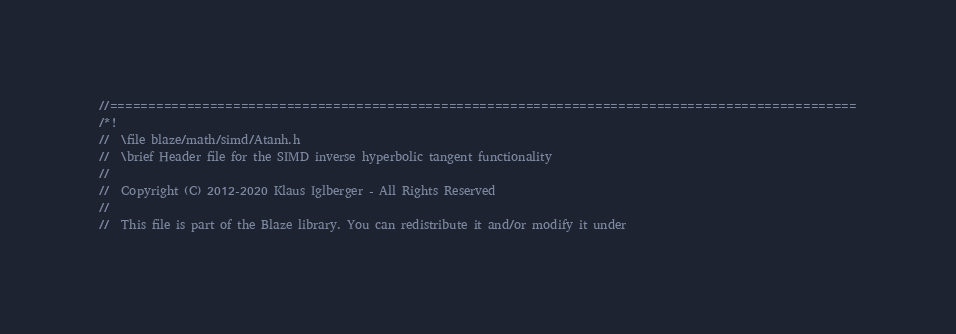<code> <loc_0><loc_0><loc_500><loc_500><_C_>//=================================================================================================
/*!
//  \file blaze/math/simd/Atanh.h
//  \brief Header file for the SIMD inverse hyperbolic tangent functionality
//
//  Copyright (C) 2012-2020 Klaus Iglberger - All Rights Reserved
//
//  This file is part of the Blaze library. You can redistribute it and/or modify it under</code> 